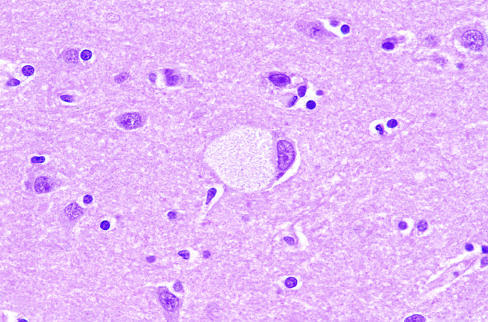does reversibly injured myocardium have obvious lipid vacuolation under the light microscope?
Answer the question using a single word or phrase. No 